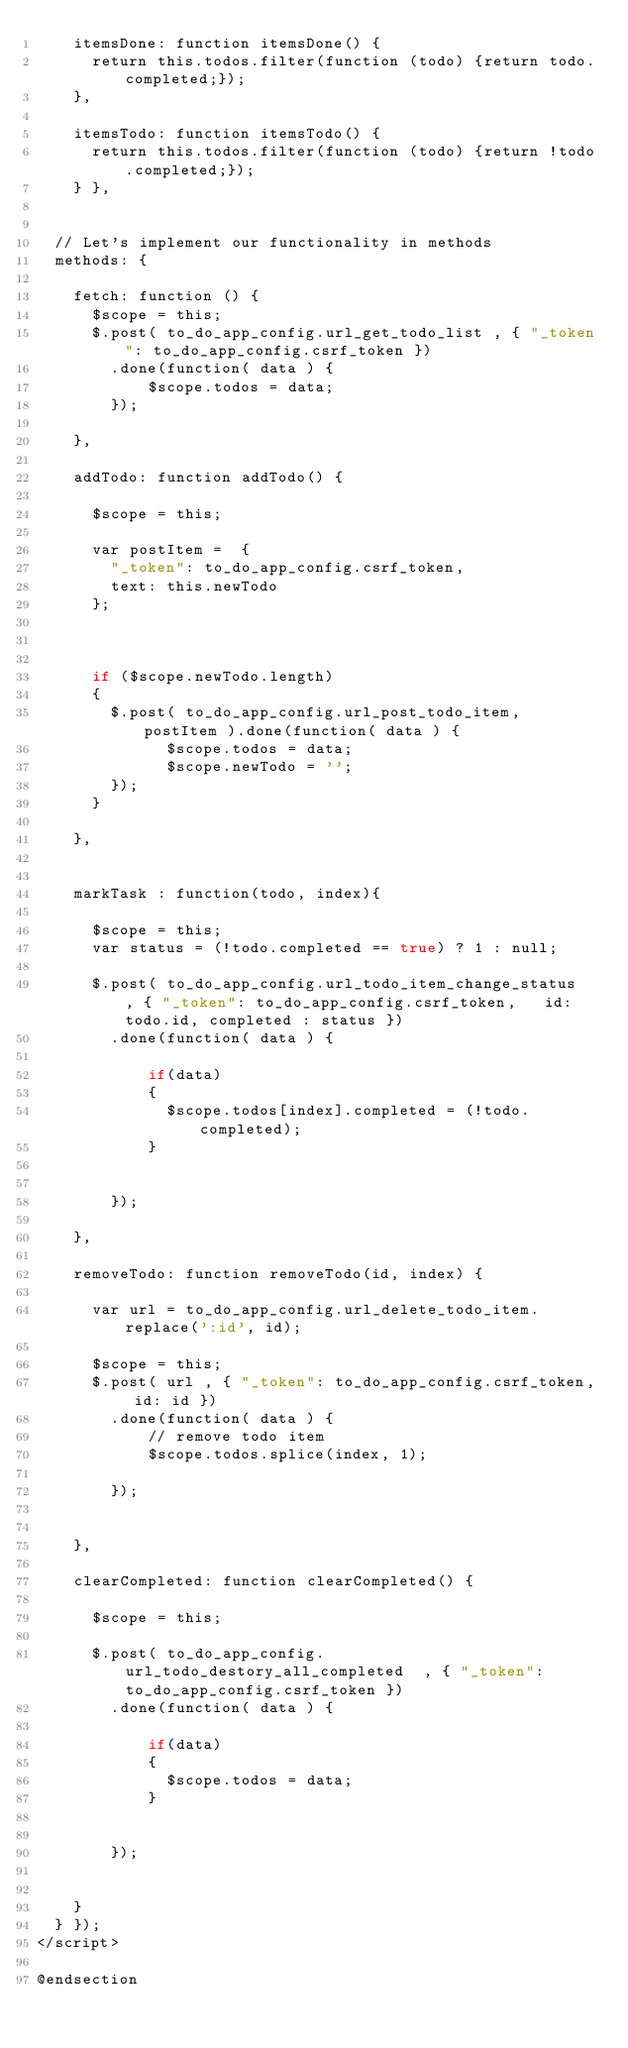Convert code to text. <code><loc_0><loc_0><loc_500><loc_500><_PHP_>    itemsDone: function itemsDone() {
      return this.todos.filter(function (todo) {return todo.completed;});
    },

    itemsTodo: function itemsTodo() {
      return this.todos.filter(function (todo) {return !todo.completed;});
    } },


  // Let's implement our functionality in methods
  methods: {

    fetch: function () {
      $scope = this;
      $.post( to_do_app_config.url_get_todo_list , { "_token": to_do_app_config.csrf_token })
        .done(function( data ) {
            $scope.todos = data;
        });

    },

    addTodo: function addTodo() {
 
      $scope = this;
      
      var postItem =  { 
        "_token": to_do_app_config.csrf_token, 
        text: this.newTodo        
      };

      
      
      if ($scope.newTodo.length) 
      {
        $.post( to_do_app_config.url_post_todo_item, postItem ).done(function( data ) {        
              $scope.todos = data;
              $scope.newTodo = '';
        });
      }
        
    },


    markTask : function(todo, index){
   
      $scope = this;
      var status = (!todo.completed == true) ? 1 : null;

      $.post( to_do_app_config.url_todo_item_change_status  , { "_token": to_do_app_config.csrf_token,   id: todo.id, completed : status })
        .done(function( data ) {            
           
            if(data)
            {
              $scope.todos[index].completed = (!todo.completed);
            }    
          

        });

    },

    removeTodo: function removeTodo(id, index) {  

      var url = to_do_app_config.url_delete_todo_item.replace(':id', id);

      $scope = this;
      $.post( url , { "_token": to_do_app_config.csrf_token, id: id })
        .done(function( data ) {            
            // remove todo item       
            $scope.todos.splice(index, 1);

        });

      
    },

    clearCompleted: function clearCompleted() { 

      $scope = this;     
      
      $.post( to_do_app_config.url_todo_destory_all_completed  , { "_token": to_do_app_config.csrf_token })
        .done(function( data ) {            
           
            if(data)
            {
              $scope.todos = data;
            }    
          

        });


    } 
  } });
</script>

@endsection</code> 